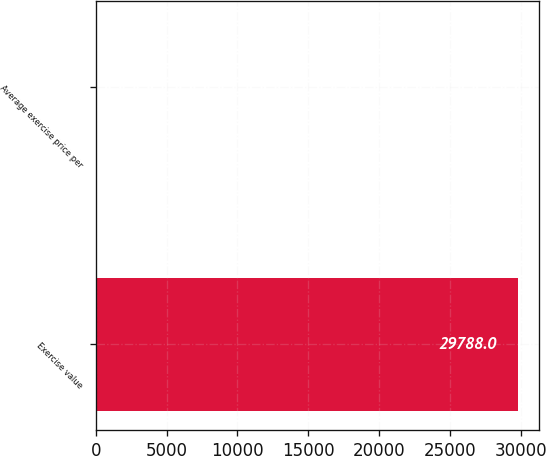<chart> <loc_0><loc_0><loc_500><loc_500><bar_chart><fcel>Exercise value<fcel>Average exercise price per<nl><fcel>29788<fcel>18.16<nl></chart> 